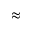Convert formula to latex. <formula><loc_0><loc_0><loc_500><loc_500>\approx</formula> 